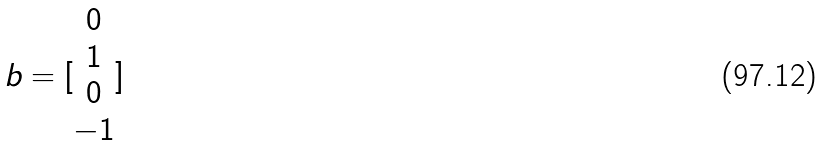Convert formula to latex. <formula><loc_0><loc_0><loc_500><loc_500>b = [ \begin{matrix} 0 \\ 1 \\ 0 \\ - 1 \end{matrix} ]</formula> 